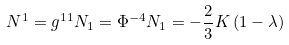Convert formula to latex. <formula><loc_0><loc_0><loc_500><loc_500>N ^ { 1 } = g ^ { 1 1 } N _ { 1 } = \Phi ^ { - 4 } N _ { 1 } = - \frac { 2 } { 3 } K \left ( 1 - \lambda \right )</formula> 